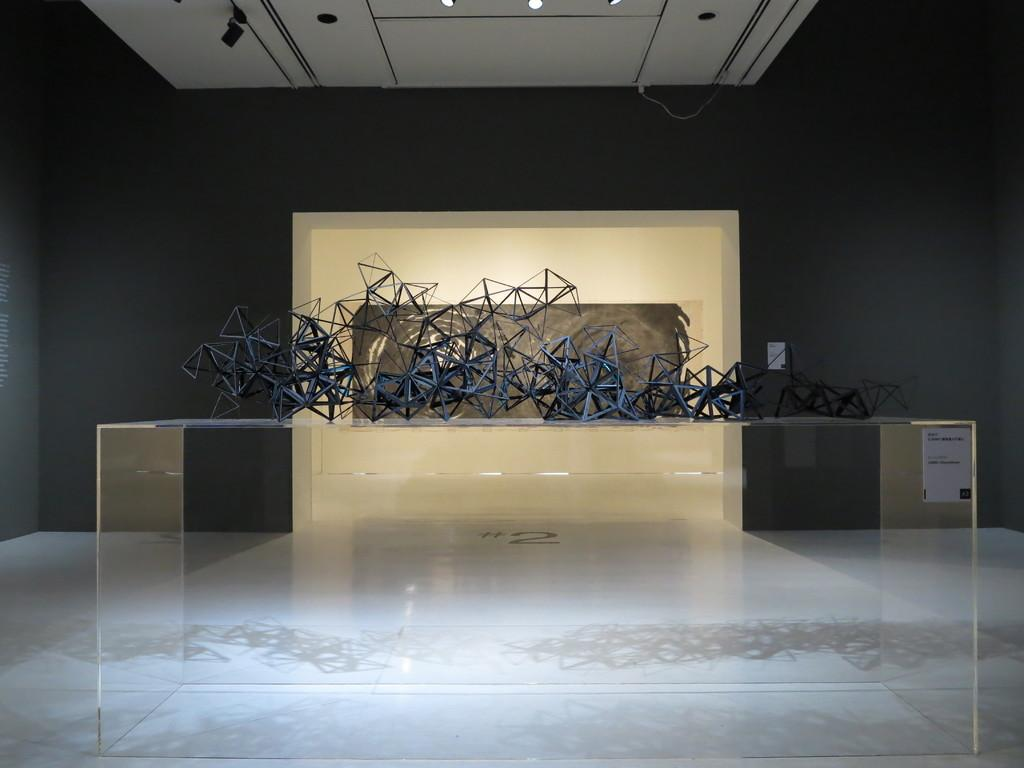What is the surface on which the objects are placed in the image? There is a glass table on which the objects are placed in the image. What can be seen in the background of the image? There is a wall in the background of the image. What is visible at the top of the image? There is a ceiling with lights visible at the top of the image. How many spiders are crawling on the objects placed on the glass table in the image? There are no spiders visible on the objects placed on the glass table in the image. What type of crack can be seen on the ceiling with lights in the image? There is no crack visible on the ceiling with lights in the image. 